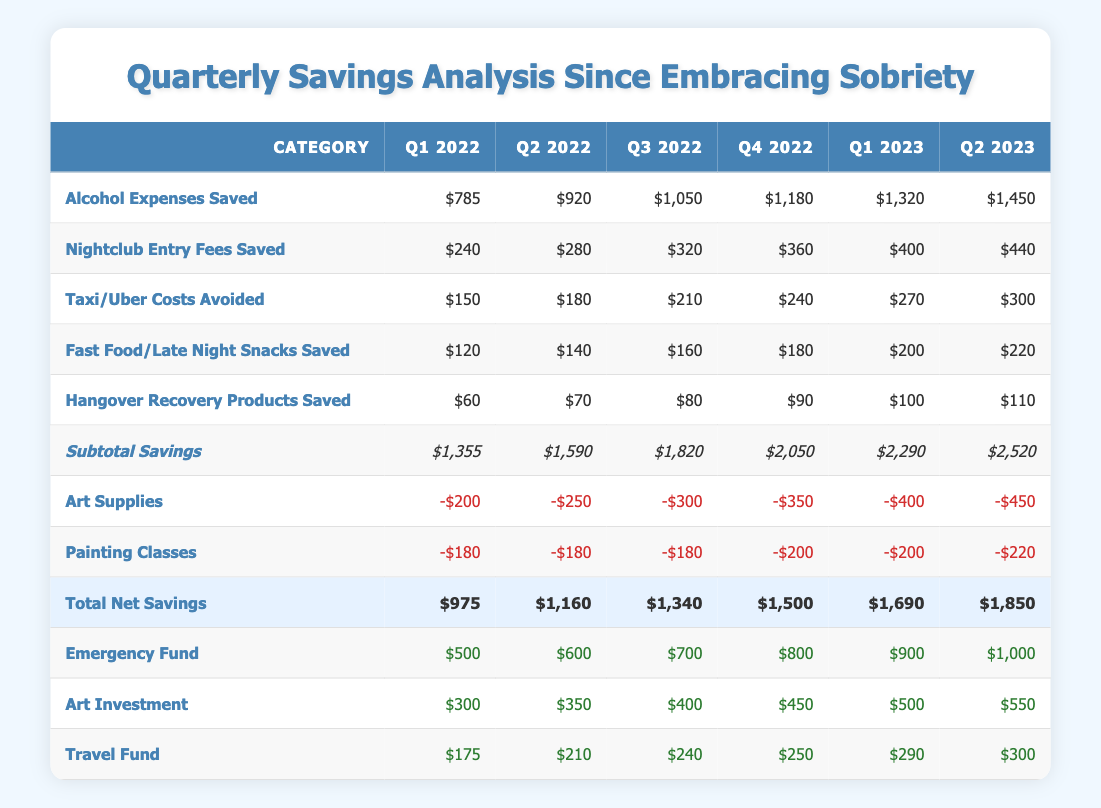What was the total net savings in Q2 2023? The total net savings in Q2 2023 can be found in the last row of the table under the "Total Net Savings" category, corresponding to Q2 2023, which is $1,850
Answer: 1,850 How much did I save from Alcohol Expenses in Q4 2022 compared to Q1 2023? In Q4 2022, the savings from Alcohol Expenses are $1,180, and in Q1 2023, they are $1,320. The difference is calculated as $1,320 - $1,180 = $140
Answer: 140 What is the average amount saved from Taxi/Uber Costs avoided over all quarters? To find the average, sum the Taxi/Uber savings over all quarters: 150 + 180 + 210 + 240 + 270 + 300 = 1350. Then divide by the number of quarters (6): 1350/6 = 225
Answer: 225 Did my savings for Fast Food/Late Night Snacks Saved exceed $200 in Q1 2023? In Q1 2023, the saving for Fast Food/Late Night Snacks is $200, which means it does not exceed $200. This is a fact-based evaluation of the provided data
Answer: No By how much has the total net savings increased from Q1 2022 to Q2 2023? The total net savings in Q1 2022 is $975, and in Q2 2023 it is $1,850. The increase can be calculated as $1,850 - $975 = $875
Answer: 875 What percentage of total savings in Q3 2022 went towards the Emergency Fund? In Q3 2022, the total savings amount to $1,340, and the Emergency Fund allocation is $700. To find the percentage, use the formula: (700 / 1340) * 100 = 52.24%. This represents the proportion of the total savings allocated to the Emergency Fund
Answer: 52.24% Was there an increase in spending on Painting Classes from Q2 2023 to Q1 2023? The spending on Painting Classes in Q1 2023 is $200, and in Q2 2023 it is $220. The spending increased by $220 - $200 = $20
Answer: Yes What was the total amount saved from Hangover Recovery Products across all quarters? To find the total amount saved from Hangover Recovery Products, sum up the values: 60 + 70 + 80 + 90 + 100 + 110 = 510
Answer: 510 